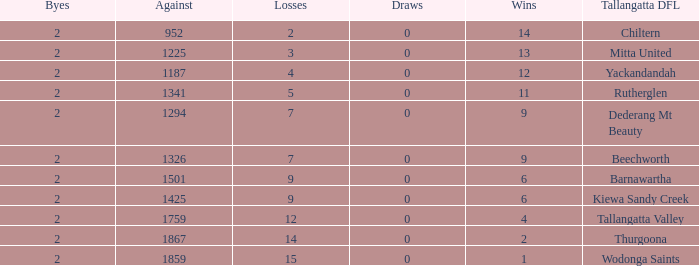What are the fewest draws with less than 7 losses and Mitta United is the Tallagatta DFL? 0.0. 